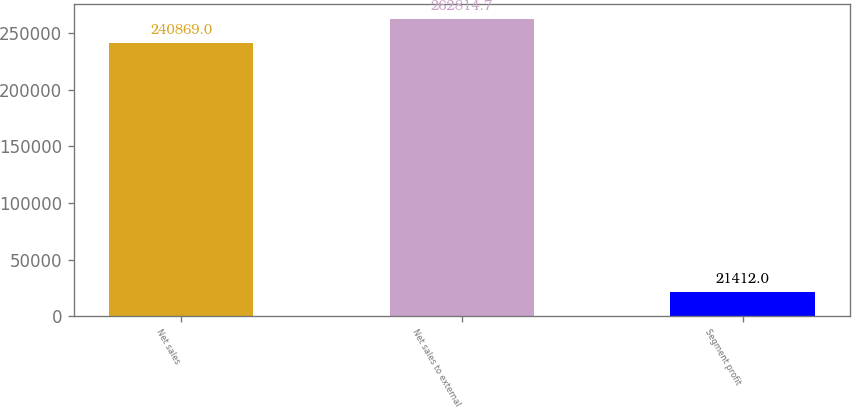<chart> <loc_0><loc_0><loc_500><loc_500><bar_chart><fcel>Net sales<fcel>Net sales to external<fcel>Segment profit<nl><fcel>240869<fcel>262815<fcel>21412<nl></chart> 